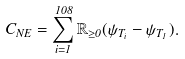Convert formula to latex. <formula><loc_0><loc_0><loc_500><loc_500>C _ { N E } = \sum _ { i = 1 } ^ { 1 0 8 } \mathbb { R } _ { \geq 0 } ( \psi _ { T _ { i } } - \psi _ { T _ { 1 } } ) .</formula> 